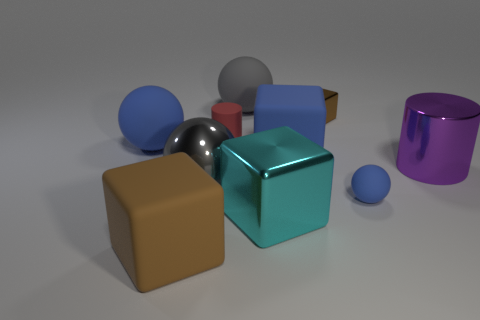Is the big brown block made of the same material as the gray sphere in front of the small metallic cube?
Offer a very short reply. No. The other cube that is made of the same material as the large cyan block is what size?
Provide a succinct answer. Small. Are there more rubber cylinders on the right side of the small block than small spheres to the right of the purple metallic cylinder?
Provide a succinct answer. No. Is there a tiny red rubber object of the same shape as the big purple thing?
Your answer should be compact. Yes. Is the size of the rubber block that is on the right side of the gray matte ball the same as the tiny blue rubber thing?
Offer a very short reply. No. Are any red metallic cylinders visible?
Your response must be concise. No. What number of objects are either blue things that are in front of the metallic sphere or big blue objects?
Make the answer very short. 3. Is the color of the small ball the same as the large cube that is behind the metal cylinder?
Give a very brief answer. Yes. Is there a metal block of the same size as the matte cylinder?
Make the answer very short. Yes. There is a brown cube behind the blue rubber sphere that is to the right of the gray matte object; what is its material?
Your answer should be compact. Metal. 